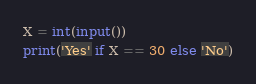Convert code to text. <code><loc_0><loc_0><loc_500><loc_500><_Python_>X = int(input())
print('Yes' if X == 30 else 'No')</code> 